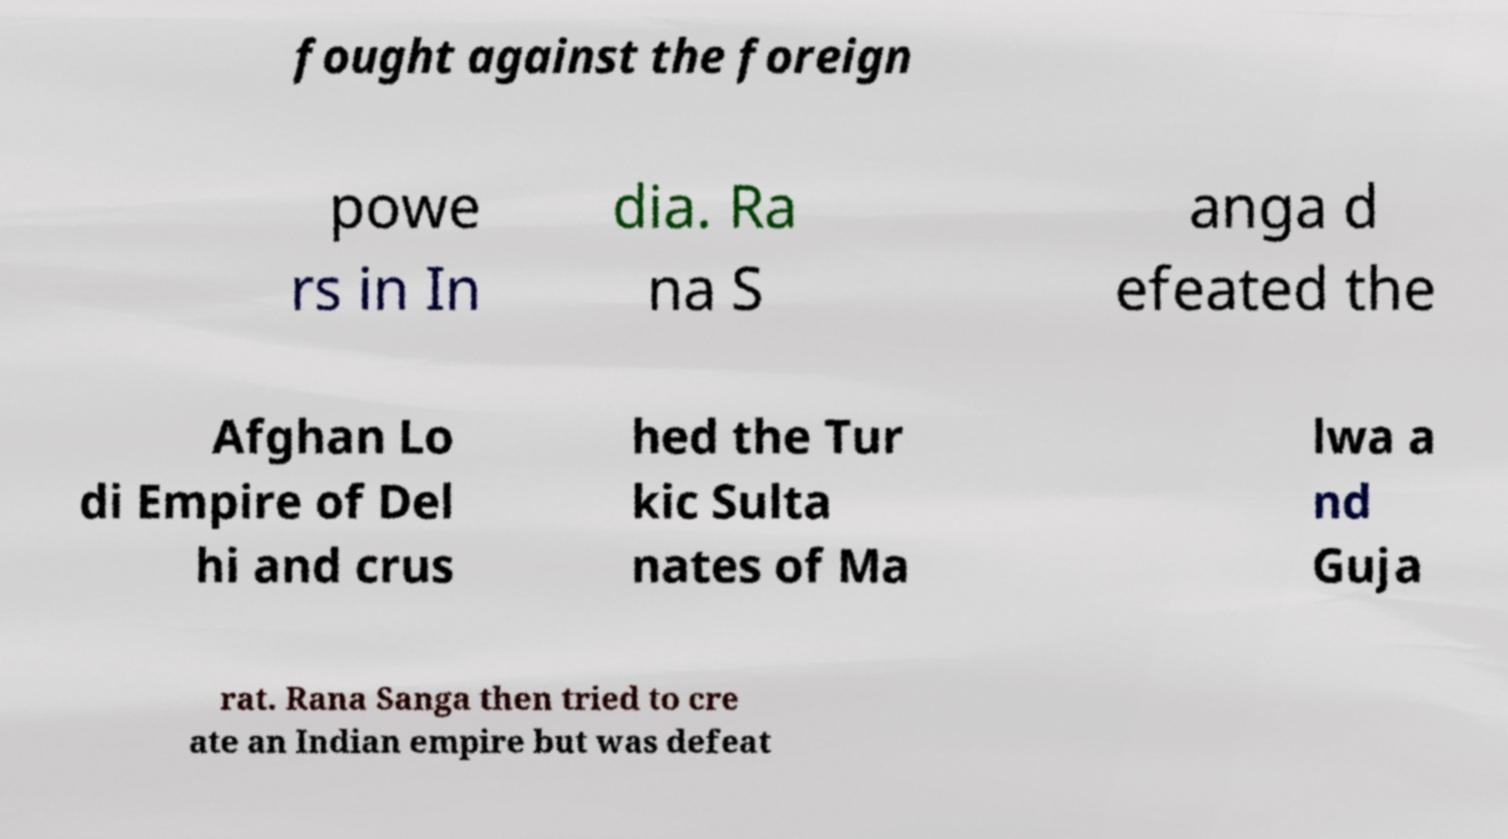I need the written content from this picture converted into text. Can you do that? fought against the foreign powe rs in In dia. Ra na S anga d efeated the Afghan Lo di Empire of Del hi and crus hed the Tur kic Sulta nates of Ma lwa a nd Guja rat. Rana Sanga then tried to cre ate an Indian empire but was defeat 